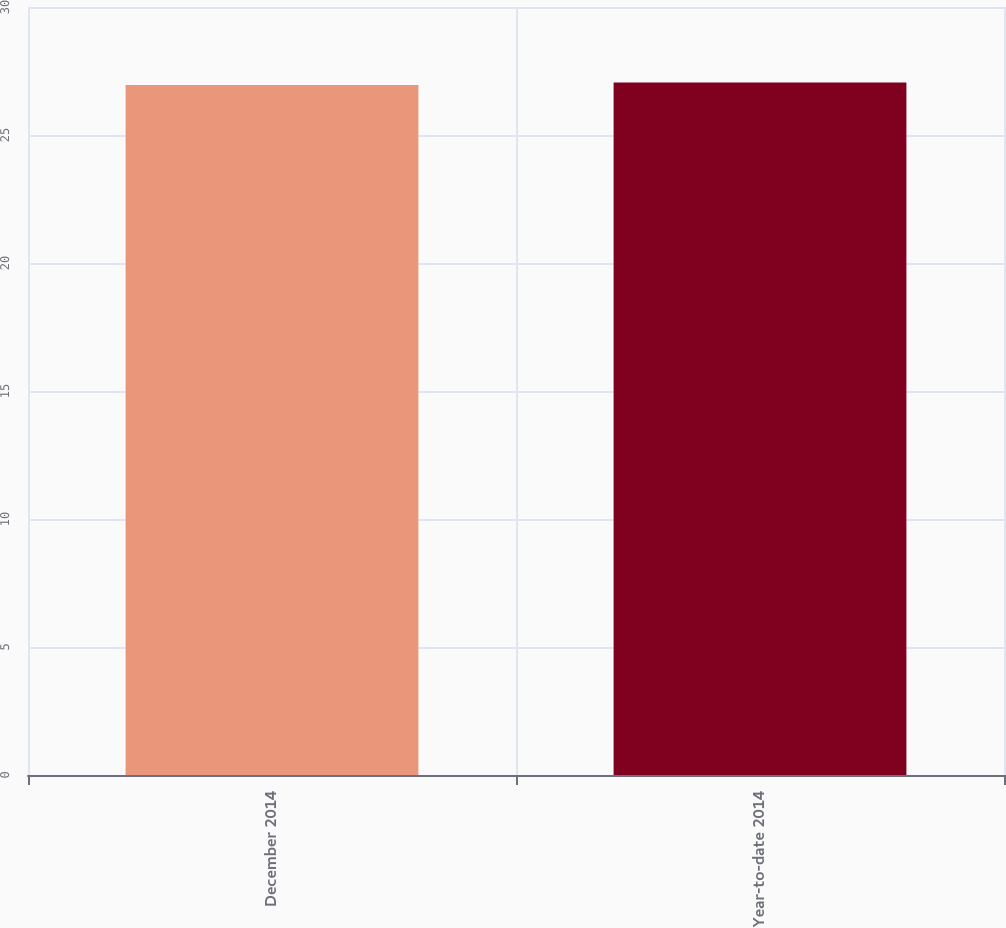Convert chart to OTSL. <chart><loc_0><loc_0><loc_500><loc_500><bar_chart><fcel>December 2014<fcel>Year-to-date 2014<nl><fcel>26.95<fcel>27.05<nl></chart> 